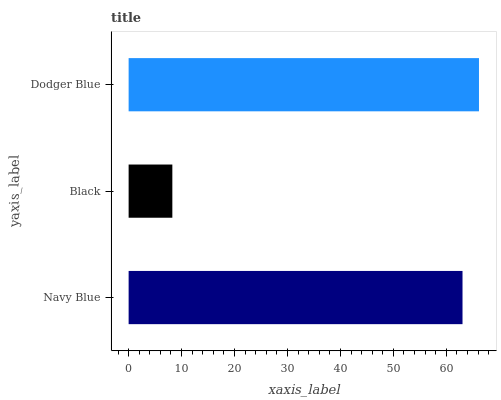Is Black the minimum?
Answer yes or no. Yes. Is Dodger Blue the maximum?
Answer yes or no. Yes. Is Dodger Blue the minimum?
Answer yes or no. No. Is Black the maximum?
Answer yes or no. No. Is Dodger Blue greater than Black?
Answer yes or no. Yes. Is Black less than Dodger Blue?
Answer yes or no. Yes. Is Black greater than Dodger Blue?
Answer yes or no. No. Is Dodger Blue less than Black?
Answer yes or no. No. Is Navy Blue the high median?
Answer yes or no. Yes. Is Navy Blue the low median?
Answer yes or no. Yes. Is Black the high median?
Answer yes or no. No. Is Black the low median?
Answer yes or no. No. 